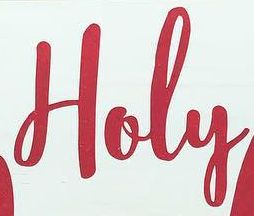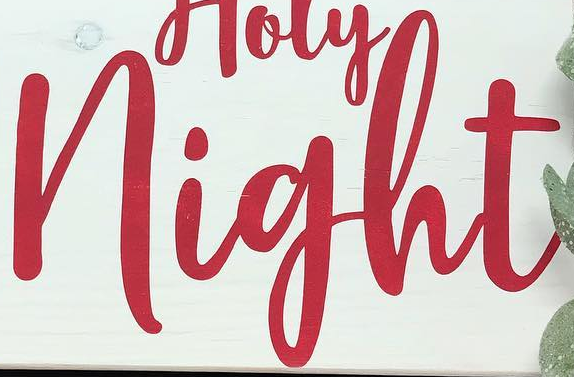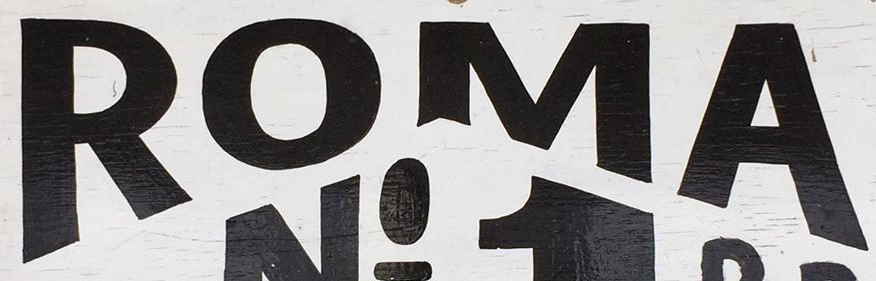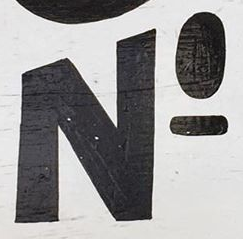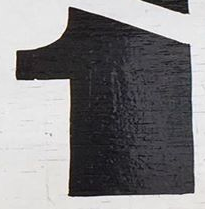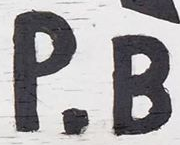What text is displayed in these images sequentially, separated by a semicolon? Holy; night; ROMA; NO; 1; P.B 